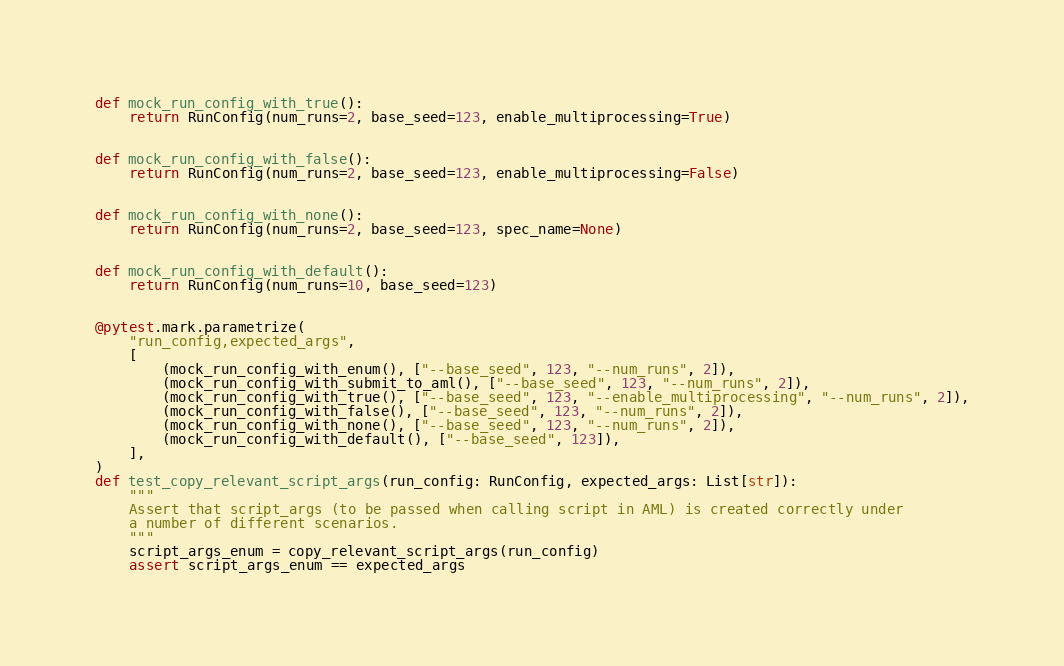<code> <loc_0><loc_0><loc_500><loc_500><_Python_>
def mock_run_config_with_true():
    return RunConfig(num_runs=2, base_seed=123, enable_multiprocessing=True)


def mock_run_config_with_false():
    return RunConfig(num_runs=2, base_seed=123, enable_multiprocessing=False)


def mock_run_config_with_none():
    return RunConfig(num_runs=2, base_seed=123, spec_name=None)


def mock_run_config_with_default():
    return RunConfig(num_runs=10, base_seed=123)


@pytest.mark.parametrize(
    "run_config,expected_args",
    [
        (mock_run_config_with_enum(), ["--base_seed", 123, "--num_runs", 2]),
        (mock_run_config_with_submit_to_aml(), ["--base_seed", 123, "--num_runs", 2]),
        (mock_run_config_with_true(), ["--base_seed", 123, "--enable_multiprocessing", "--num_runs", 2]),
        (mock_run_config_with_false(), ["--base_seed", 123, "--num_runs", 2]),
        (mock_run_config_with_none(), ["--base_seed", 123, "--num_runs", 2]),
        (mock_run_config_with_default(), ["--base_seed", 123]),
    ],
)
def test_copy_relevant_script_args(run_config: RunConfig, expected_args: List[str]):
    """
    Assert that script_args (to be passed when calling script in AML) is created correctly under
    a number of different scenarios.
    """
    script_args_enum = copy_relevant_script_args(run_config)
    assert script_args_enum == expected_args
</code> 